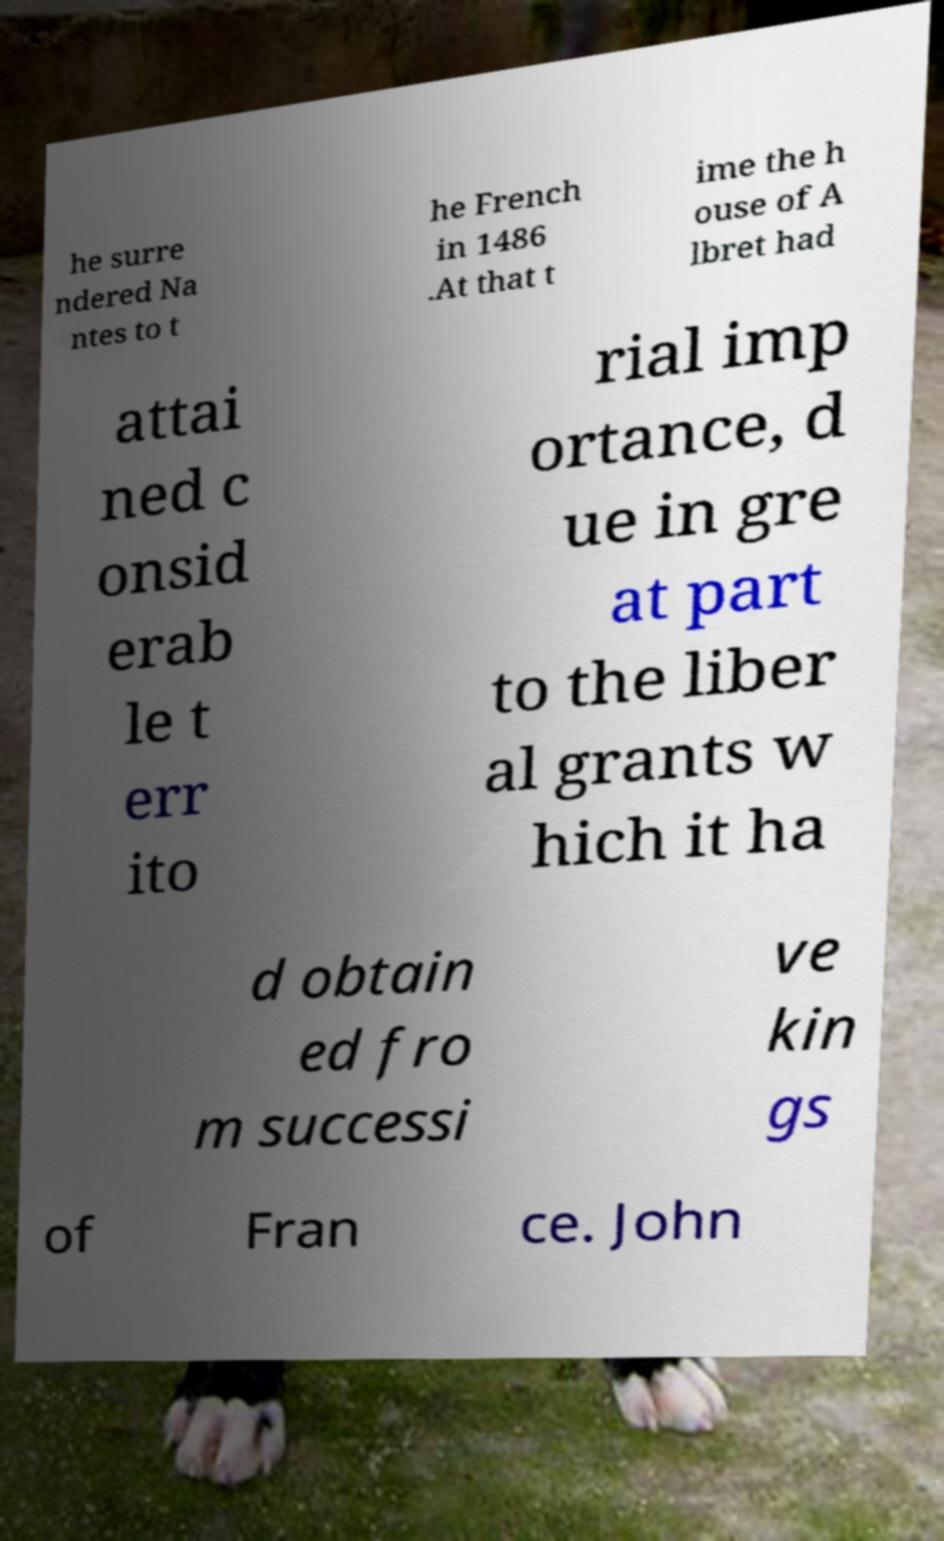Could you extract and type out the text from this image? he surre ndered Na ntes to t he French in 1486 .At that t ime the h ouse of A lbret had attai ned c onsid erab le t err ito rial imp ortance, d ue in gre at part to the liber al grants w hich it ha d obtain ed fro m successi ve kin gs of Fran ce. John 